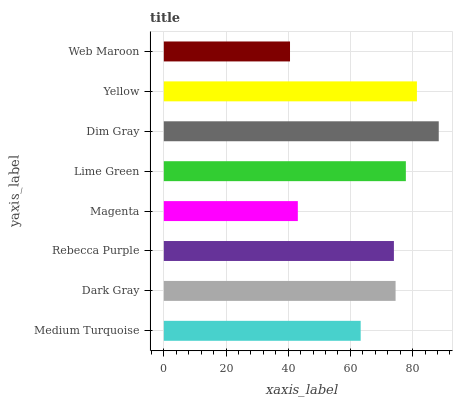Is Web Maroon the minimum?
Answer yes or no. Yes. Is Dim Gray the maximum?
Answer yes or no. Yes. Is Dark Gray the minimum?
Answer yes or no. No. Is Dark Gray the maximum?
Answer yes or no. No. Is Dark Gray greater than Medium Turquoise?
Answer yes or no. Yes. Is Medium Turquoise less than Dark Gray?
Answer yes or no. Yes. Is Medium Turquoise greater than Dark Gray?
Answer yes or no. No. Is Dark Gray less than Medium Turquoise?
Answer yes or no. No. Is Dark Gray the high median?
Answer yes or no. Yes. Is Rebecca Purple the low median?
Answer yes or no. Yes. Is Rebecca Purple the high median?
Answer yes or no. No. Is Lime Green the low median?
Answer yes or no. No. 